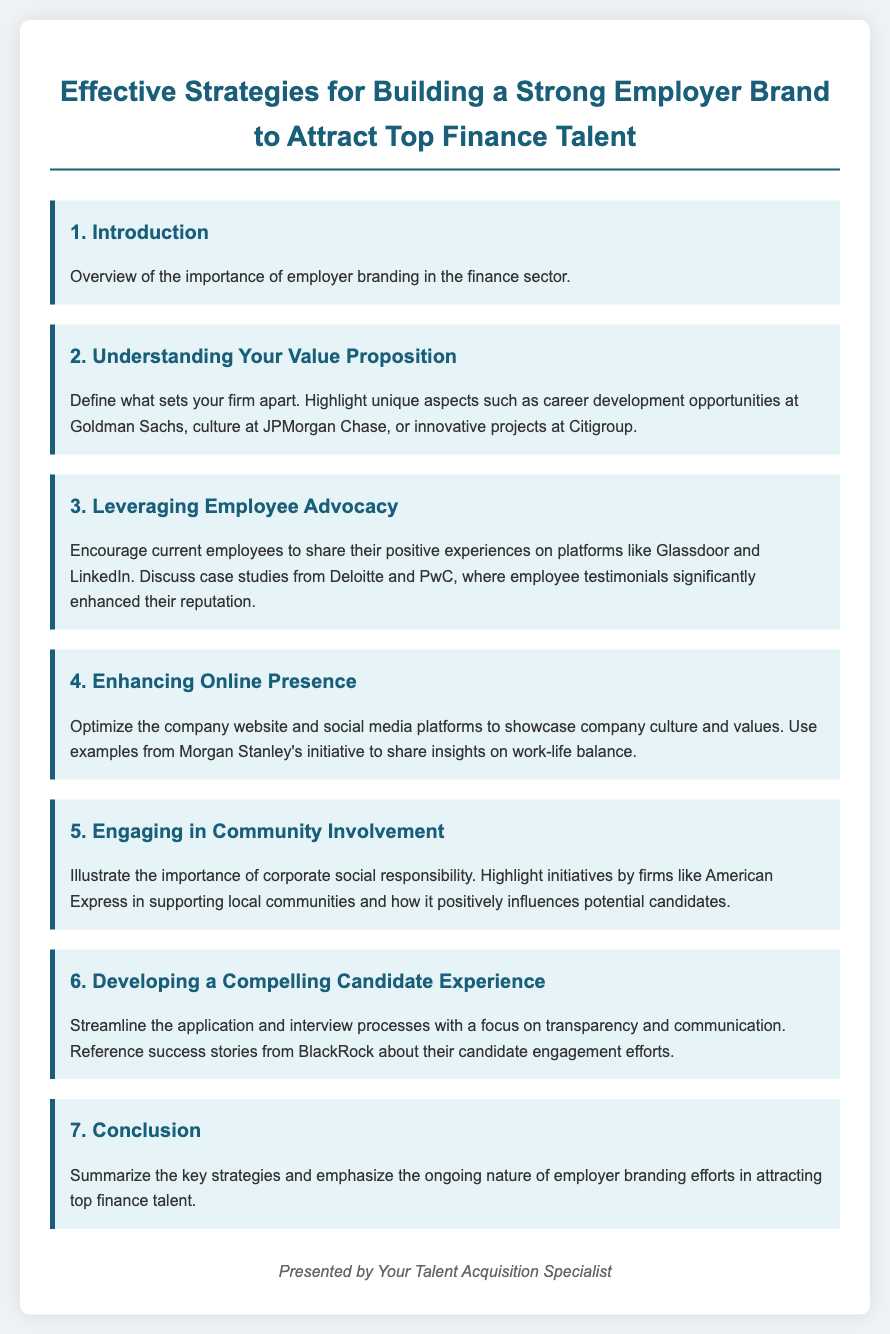What is the title of the document? The title is stated at the top of the document, clearly indicating the focus on employer branding in the finance sector.
Answer: Effective Strategies for Building a Strong Employer Brand to Attract Top Finance Talent What company is mentioned in relation to career development opportunities? The document highlights specific companies to illustrate unique aspects of employer branding, including this firm.
Answer: Goldman Sachs Which aspect of employee advocacy is discussed? The section emphasizes current employees sharing positive experiences, which is a key point in leveraging employee advocacy.
Answer: Sharing positive experiences What is one example of a firm mentioned in enhancing its online presence? The document provides examples of companies to showcase effective strategies; this specific firm is highlighted.
Answer: Morgan Stanley How many main agenda points are listed? The document presents a structured agenda, so counting the items helps in understanding its organization.
Answer: 7 